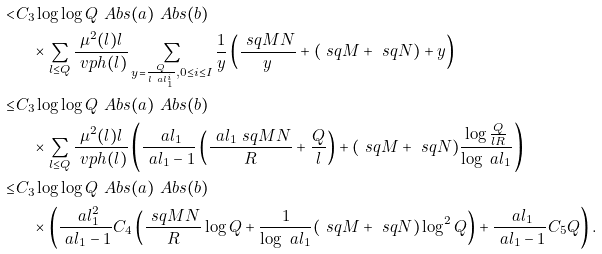<formula> <loc_0><loc_0><loc_500><loc_500>< & C _ { 3 } \log \log Q \ A b s { ( a ) } \ A b s { ( b ) } \\ & \quad \times \sum _ { l \leq Q } \frac { \mu ^ { 2 } ( l ) l } { \ v p h ( l ) } \sum _ { \substack { y = \frac { Q } { l \ a l _ { 1 } ^ { i } } , 0 \leq i \leq I } } \frac { 1 } { y } \left ( \frac { \ s q { M N } } { y } + ( \ s q { M } + \ s q { N } ) + y \right ) \\ \leq & C _ { 3 } \log \log Q \ A b s { ( a ) } \ A b s { ( b ) } \\ & \quad \times \sum _ { l \leq Q } \frac { \mu ^ { 2 } ( l ) l } { \ v p h ( l ) } \left ( \frac { \ a l _ { 1 } } { \ a l _ { 1 } - 1 } \left ( \frac { \ a l _ { 1 } \ s q { M N } } { R } + \frac { Q } { l } \right ) + ( \ s q { M } + \ s q { N } ) \frac { \log \frac { Q } { l R } } { \log \ a l _ { 1 } } \right ) \\ \leq & C _ { 3 } \log \log Q \ A b s { ( a ) } \ A b s { ( b ) } \\ & \quad \times \left ( \frac { \ a l _ { 1 } ^ { 2 } } { \ a l _ { 1 } - 1 } C _ { 4 } \left ( \frac { \ s q { M N } } { R } \log Q + \frac { 1 } { \log \ a l _ { 1 } } ( \ s q { M } + \ s q { N } ) \log ^ { 2 } Q \right ) + \frac { \ a l _ { 1 } } { \ a l _ { 1 } - 1 } C _ { 5 } Q \right ) .</formula> 